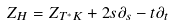<formula> <loc_0><loc_0><loc_500><loc_500>Z _ { H } = Z _ { T ^ { * } K } + 2 s \partial _ { s } - t \partial _ { t }</formula> 